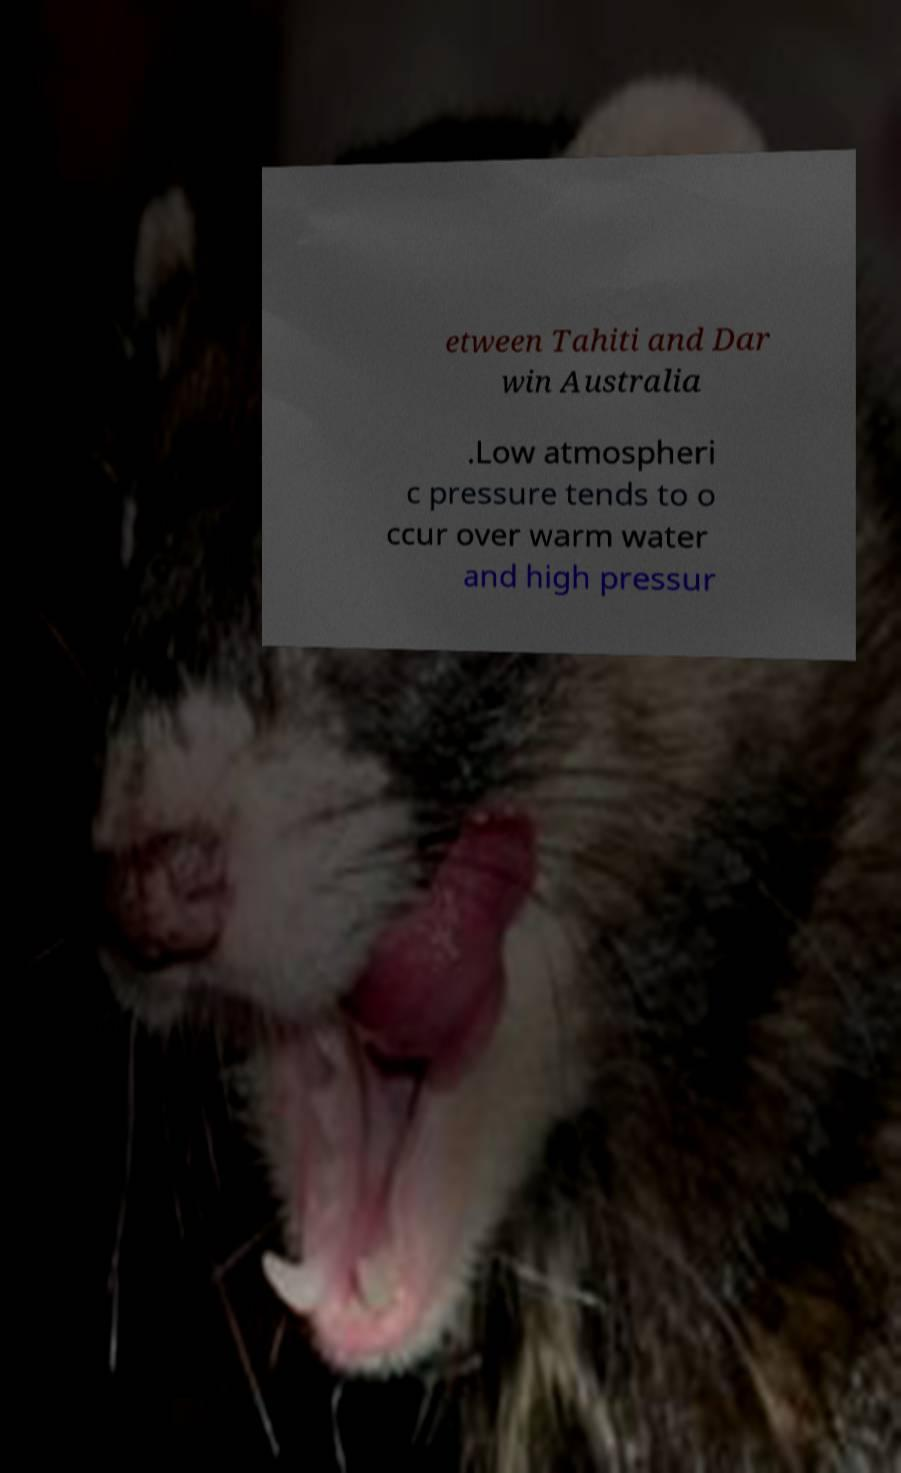Could you extract and type out the text from this image? etween Tahiti and Dar win Australia .Low atmospheri c pressure tends to o ccur over warm water and high pressur 